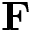<formula> <loc_0><loc_0><loc_500><loc_500>\mathbf F</formula> 